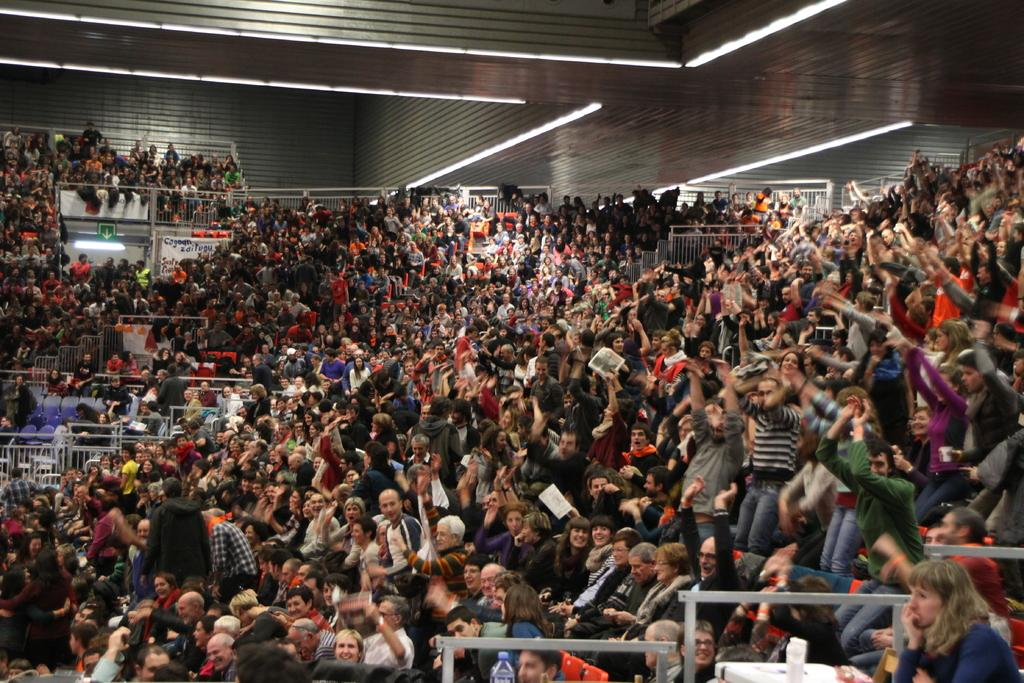How many people are in the image? There is a group of people in the image, but the exact number is not specified. What are the people in the image doing? Some people are sitting, while others are standing. What are the standing people holding? The standing people are holding something, but the specific item is not mentioned. What can be seen hanging in the image? There is a banner in the image. What is the other flat surface visible in the image? There is a board in the image. What type of illumination is present in the image? There are lights in the image. What is visible at the top of the image? The ceiling is visible at the top of the image. What type of books are being cooked on the stove in the image? There is no stove or books present in the image. 